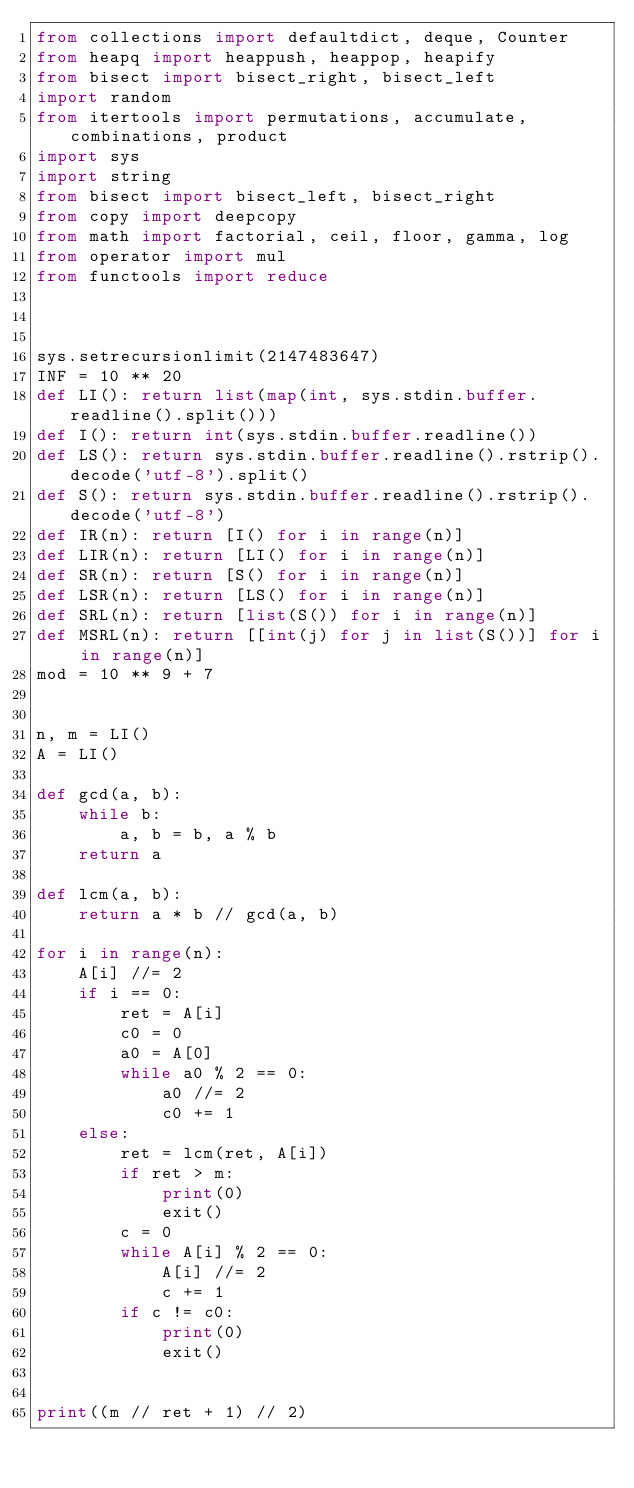<code> <loc_0><loc_0><loc_500><loc_500><_Python_>from collections import defaultdict, deque, Counter
from heapq import heappush, heappop, heapify
from bisect import bisect_right, bisect_left
import random
from itertools import permutations, accumulate, combinations, product
import sys
import string
from bisect import bisect_left, bisect_right
from copy import deepcopy
from math import factorial, ceil, floor, gamma, log
from operator import mul
from functools import reduce



sys.setrecursionlimit(2147483647)
INF = 10 ** 20
def LI(): return list(map(int, sys.stdin.buffer.readline().split()))
def I(): return int(sys.stdin.buffer.readline())
def LS(): return sys.stdin.buffer.readline().rstrip().decode('utf-8').split()
def S(): return sys.stdin.buffer.readline().rstrip().decode('utf-8')
def IR(n): return [I() for i in range(n)]
def LIR(n): return [LI() for i in range(n)]
def SR(n): return [S() for i in range(n)]
def LSR(n): return [LS() for i in range(n)]
def SRL(n): return [list(S()) for i in range(n)]
def MSRL(n): return [[int(j) for j in list(S())] for i in range(n)]
mod = 10 ** 9 + 7


n, m = LI()
A = LI()

def gcd(a, b):
    while b:
        a, b = b, a % b
    return a

def lcm(a, b):
    return a * b // gcd(a, b)

for i in range(n):
    A[i] //= 2
    if i == 0:
        ret = A[i]
        c0 = 0
        a0 = A[0]
        while a0 % 2 == 0:
            a0 //= 2
            c0 += 1
    else:
        ret = lcm(ret, A[i])
        if ret > m:
            print(0)
            exit()
        c = 0
        while A[i] % 2 == 0:
            A[i] //= 2
            c += 1
        if c != c0:
            print(0)
            exit()


print((m // ret + 1) // 2)</code> 